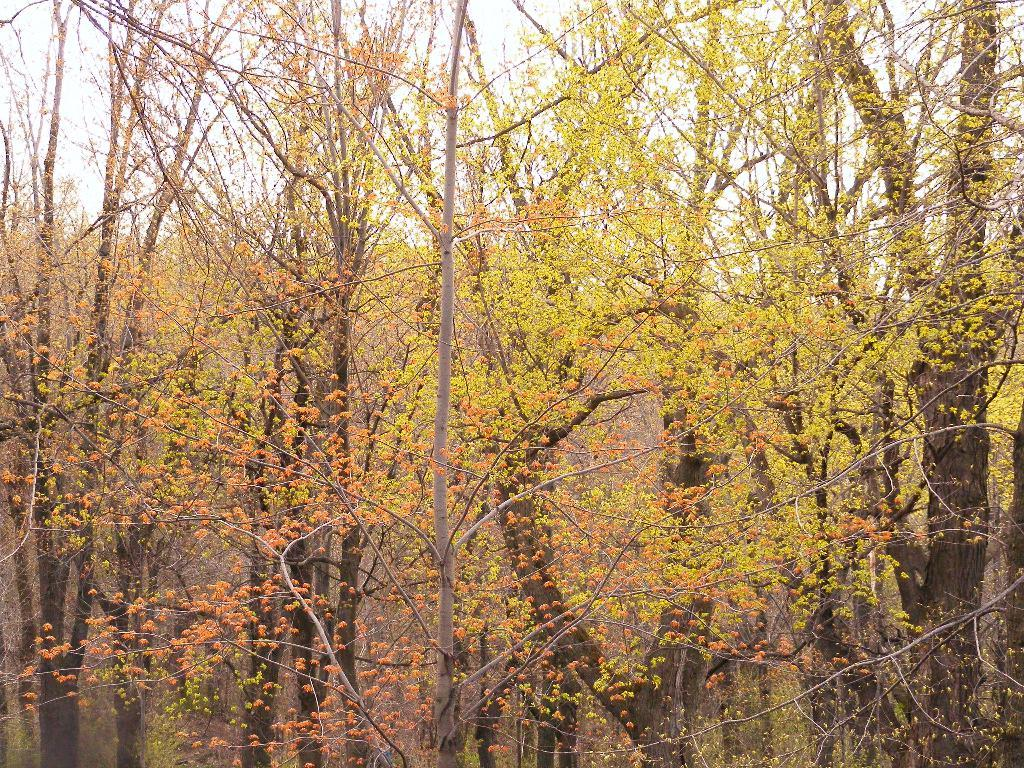What color are the trees in the image? The trees in the image are yellow. What else can be seen in the image besides the trees? The sky is visible in the image. Can you tell me how many clovers are growing under the yellow trees in the image? There is no mention of clovers in the image, so it is impossible to determine how many there are. 